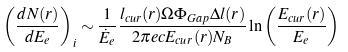<formula> <loc_0><loc_0><loc_500><loc_500>\left ( \frac { d N ( r ) } { d E _ { e } } \right ) _ { i } \sim \frac { 1 } { \dot { E } _ { e } } \frac { l _ { c u r } ( r ) \Omega \Phi _ { G a p } \Delta l ( r ) } { 2 \pi e c E _ { c u r } ( r ) N _ { B } } \ln \left ( \frac { E _ { c u r } ( r ) } { E _ { e } } \right )</formula> 